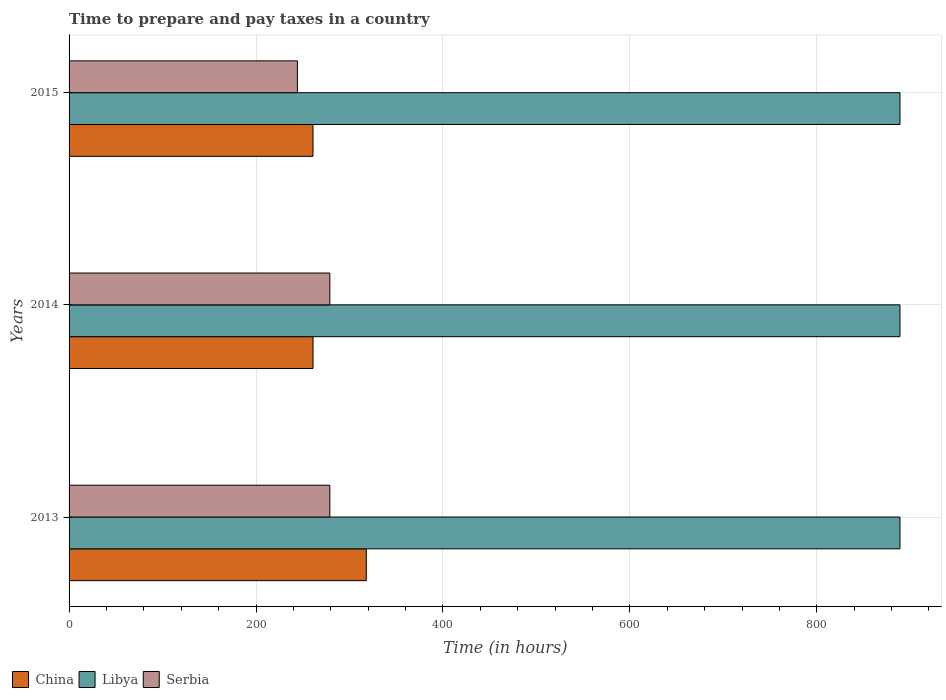How many bars are there on the 2nd tick from the top?
Offer a very short reply. 3. What is the label of the 1st group of bars from the top?
Give a very brief answer. 2015. In how many cases, is the number of bars for a given year not equal to the number of legend labels?
Your answer should be compact. 0. What is the number of hours required to prepare and pay taxes in Libya in 2015?
Provide a short and direct response. 889. Across all years, what is the maximum number of hours required to prepare and pay taxes in China?
Give a very brief answer. 318. Across all years, what is the minimum number of hours required to prepare and pay taxes in Serbia?
Provide a succinct answer. 244.3. In which year was the number of hours required to prepare and pay taxes in Serbia minimum?
Give a very brief answer. 2015. What is the total number of hours required to prepare and pay taxes in China in the graph?
Give a very brief answer. 840. What is the difference between the number of hours required to prepare and pay taxes in Serbia in 2013 and that in 2014?
Your answer should be very brief. 0. What is the difference between the number of hours required to prepare and pay taxes in Libya in 2014 and the number of hours required to prepare and pay taxes in Serbia in 2015?
Ensure brevity in your answer.  644.7. What is the average number of hours required to prepare and pay taxes in Libya per year?
Your answer should be very brief. 889. In the year 2013, what is the difference between the number of hours required to prepare and pay taxes in Serbia and number of hours required to prepare and pay taxes in China?
Your answer should be very brief. -39. What is the ratio of the number of hours required to prepare and pay taxes in China in 2013 to that in 2015?
Offer a very short reply. 1.22. Is the number of hours required to prepare and pay taxes in Serbia in 2014 less than that in 2015?
Your answer should be compact. No. What is the difference between the highest and the lowest number of hours required to prepare and pay taxes in Serbia?
Make the answer very short. 34.7. In how many years, is the number of hours required to prepare and pay taxes in Libya greater than the average number of hours required to prepare and pay taxes in Libya taken over all years?
Provide a short and direct response. 0. What does the 1st bar from the bottom in 2014 represents?
Your answer should be very brief. China. Is it the case that in every year, the sum of the number of hours required to prepare and pay taxes in Libya and number of hours required to prepare and pay taxes in Serbia is greater than the number of hours required to prepare and pay taxes in China?
Your response must be concise. Yes. How many bars are there?
Keep it short and to the point. 9. How many years are there in the graph?
Make the answer very short. 3. What is the difference between two consecutive major ticks on the X-axis?
Offer a very short reply. 200. Does the graph contain any zero values?
Your answer should be compact. No. Does the graph contain grids?
Your response must be concise. Yes. What is the title of the graph?
Provide a short and direct response. Time to prepare and pay taxes in a country. What is the label or title of the X-axis?
Your answer should be very brief. Time (in hours). What is the label or title of the Y-axis?
Provide a succinct answer. Years. What is the Time (in hours) of China in 2013?
Keep it short and to the point. 318. What is the Time (in hours) of Libya in 2013?
Make the answer very short. 889. What is the Time (in hours) of Serbia in 2013?
Make the answer very short. 279. What is the Time (in hours) of China in 2014?
Ensure brevity in your answer.  261. What is the Time (in hours) in Libya in 2014?
Your answer should be very brief. 889. What is the Time (in hours) in Serbia in 2014?
Provide a short and direct response. 279. What is the Time (in hours) of China in 2015?
Your answer should be very brief. 261. What is the Time (in hours) in Libya in 2015?
Your response must be concise. 889. What is the Time (in hours) in Serbia in 2015?
Provide a succinct answer. 244.3. Across all years, what is the maximum Time (in hours) of China?
Your answer should be very brief. 318. Across all years, what is the maximum Time (in hours) in Libya?
Your response must be concise. 889. Across all years, what is the maximum Time (in hours) of Serbia?
Keep it short and to the point. 279. Across all years, what is the minimum Time (in hours) in China?
Your answer should be compact. 261. Across all years, what is the minimum Time (in hours) in Libya?
Your answer should be compact. 889. Across all years, what is the minimum Time (in hours) in Serbia?
Provide a short and direct response. 244.3. What is the total Time (in hours) of China in the graph?
Provide a short and direct response. 840. What is the total Time (in hours) in Libya in the graph?
Give a very brief answer. 2667. What is the total Time (in hours) of Serbia in the graph?
Make the answer very short. 802.3. What is the difference between the Time (in hours) in Serbia in 2013 and that in 2014?
Ensure brevity in your answer.  0. What is the difference between the Time (in hours) of Serbia in 2013 and that in 2015?
Give a very brief answer. 34.7. What is the difference between the Time (in hours) of Serbia in 2014 and that in 2015?
Give a very brief answer. 34.7. What is the difference between the Time (in hours) in China in 2013 and the Time (in hours) in Libya in 2014?
Make the answer very short. -571. What is the difference between the Time (in hours) in China in 2013 and the Time (in hours) in Serbia in 2014?
Offer a terse response. 39. What is the difference between the Time (in hours) in Libya in 2013 and the Time (in hours) in Serbia in 2014?
Provide a succinct answer. 610. What is the difference between the Time (in hours) in China in 2013 and the Time (in hours) in Libya in 2015?
Provide a short and direct response. -571. What is the difference between the Time (in hours) in China in 2013 and the Time (in hours) in Serbia in 2015?
Ensure brevity in your answer.  73.7. What is the difference between the Time (in hours) in Libya in 2013 and the Time (in hours) in Serbia in 2015?
Provide a short and direct response. 644.7. What is the difference between the Time (in hours) in China in 2014 and the Time (in hours) in Libya in 2015?
Your answer should be compact. -628. What is the difference between the Time (in hours) in China in 2014 and the Time (in hours) in Serbia in 2015?
Your answer should be compact. 16.7. What is the difference between the Time (in hours) of Libya in 2014 and the Time (in hours) of Serbia in 2015?
Provide a succinct answer. 644.7. What is the average Time (in hours) of China per year?
Keep it short and to the point. 280. What is the average Time (in hours) in Libya per year?
Provide a succinct answer. 889. What is the average Time (in hours) of Serbia per year?
Ensure brevity in your answer.  267.43. In the year 2013, what is the difference between the Time (in hours) of China and Time (in hours) of Libya?
Provide a succinct answer. -571. In the year 2013, what is the difference between the Time (in hours) of China and Time (in hours) of Serbia?
Make the answer very short. 39. In the year 2013, what is the difference between the Time (in hours) in Libya and Time (in hours) in Serbia?
Offer a very short reply. 610. In the year 2014, what is the difference between the Time (in hours) of China and Time (in hours) of Libya?
Your answer should be very brief. -628. In the year 2014, what is the difference between the Time (in hours) of Libya and Time (in hours) of Serbia?
Offer a terse response. 610. In the year 2015, what is the difference between the Time (in hours) in China and Time (in hours) in Libya?
Offer a terse response. -628. In the year 2015, what is the difference between the Time (in hours) of Libya and Time (in hours) of Serbia?
Provide a succinct answer. 644.7. What is the ratio of the Time (in hours) in China in 2013 to that in 2014?
Your answer should be compact. 1.22. What is the ratio of the Time (in hours) in Serbia in 2013 to that in 2014?
Provide a short and direct response. 1. What is the ratio of the Time (in hours) of China in 2013 to that in 2015?
Your answer should be compact. 1.22. What is the ratio of the Time (in hours) in Serbia in 2013 to that in 2015?
Make the answer very short. 1.14. What is the ratio of the Time (in hours) of China in 2014 to that in 2015?
Your response must be concise. 1. What is the ratio of the Time (in hours) of Libya in 2014 to that in 2015?
Your answer should be compact. 1. What is the ratio of the Time (in hours) in Serbia in 2014 to that in 2015?
Offer a very short reply. 1.14. What is the difference between the highest and the second highest Time (in hours) of Libya?
Offer a terse response. 0. What is the difference between the highest and the lowest Time (in hours) in Libya?
Give a very brief answer. 0. What is the difference between the highest and the lowest Time (in hours) of Serbia?
Provide a succinct answer. 34.7. 